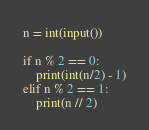Convert code to text. <code><loc_0><loc_0><loc_500><loc_500><_Python_>n = int(input())

if n % 2 == 0:
	print(int(n/2) - 1)
elif n % 2 == 1:
	print(n // 2)</code> 